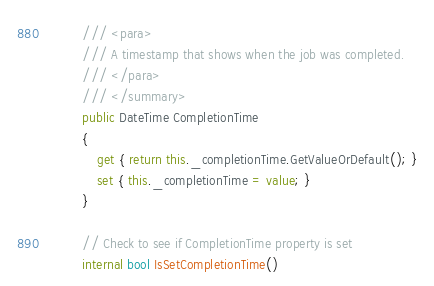Convert code to text. <code><loc_0><loc_0><loc_500><loc_500><_C#_>        /// <para>
        /// A timestamp that shows when the job was completed.
        /// </para>
        /// </summary>
        public DateTime CompletionTime
        {
            get { return this._completionTime.GetValueOrDefault(); }
            set { this._completionTime = value; }
        }

        // Check to see if CompletionTime property is set
        internal bool IsSetCompletionTime()</code> 